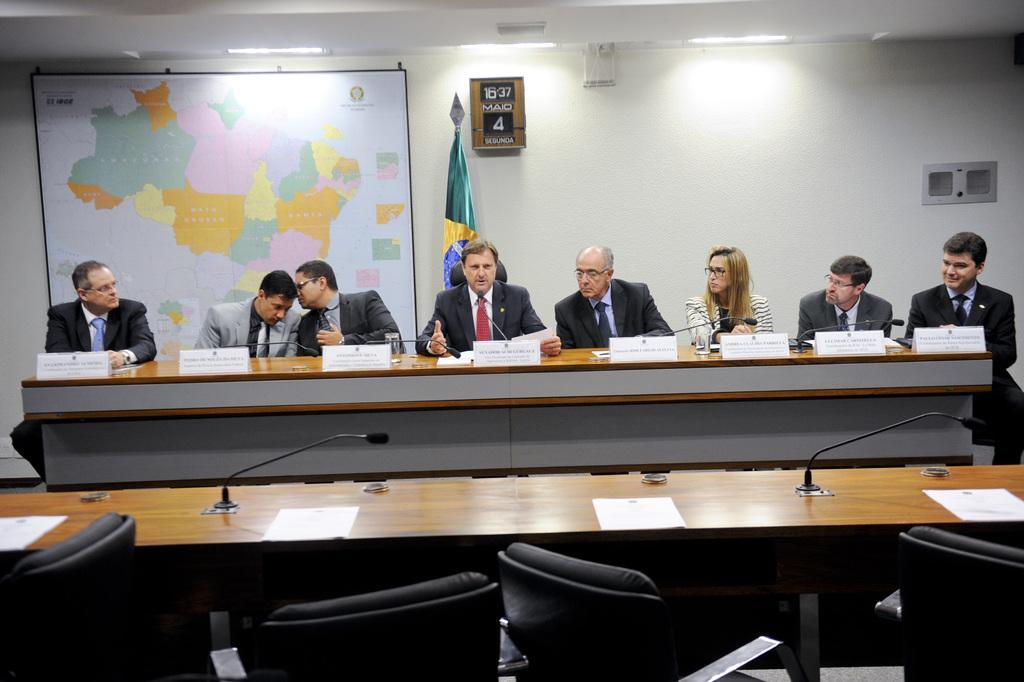In one or two sentences, can you explain what this image depicts? It is a closed room where eight people are sitting on the chairs in front of the table and on the table there are name boards, glasses and miles and behind them there is a flag and wall with a world map and a calendar box on the wall and in front of them there is an empty table and chairs. 